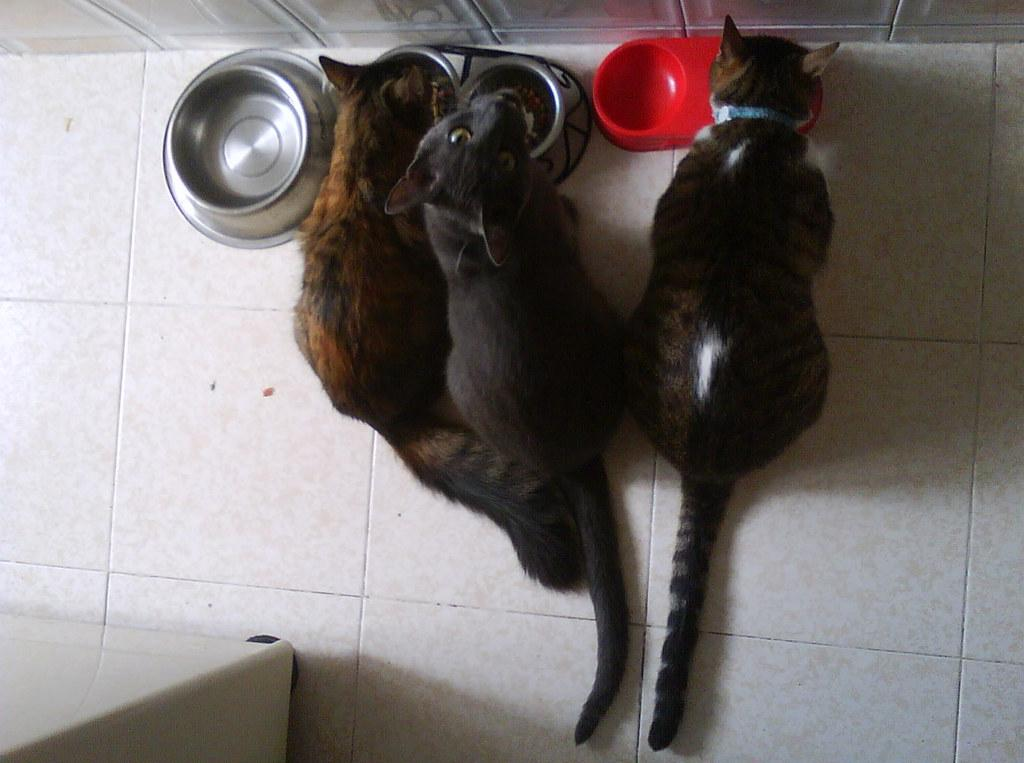What type of animals are in the image? There are cats in the image. What objects are also visible in the image? There are bowls in the image. Can you describe the white object at the bottom left of the image? There is a white object at the bottom left of the image. What is the background of the image? There is a wall at the top of the image. How many friends are visible in the image? There is no reference to friends in the image, as it features cats and other objects. 